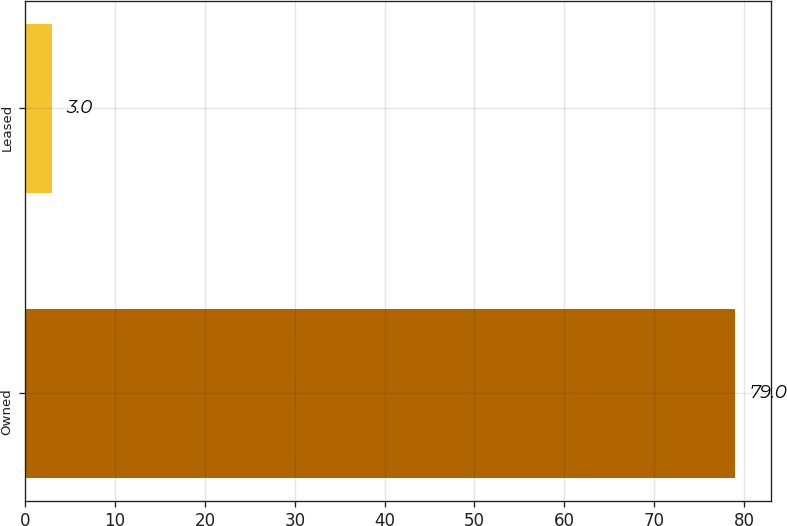Convert chart to OTSL. <chart><loc_0><loc_0><loc_500><loc_500><bar_chart><fcel>Owned<fcel>Leased<nl><fcel>79<fcel>3<nl></chart> 